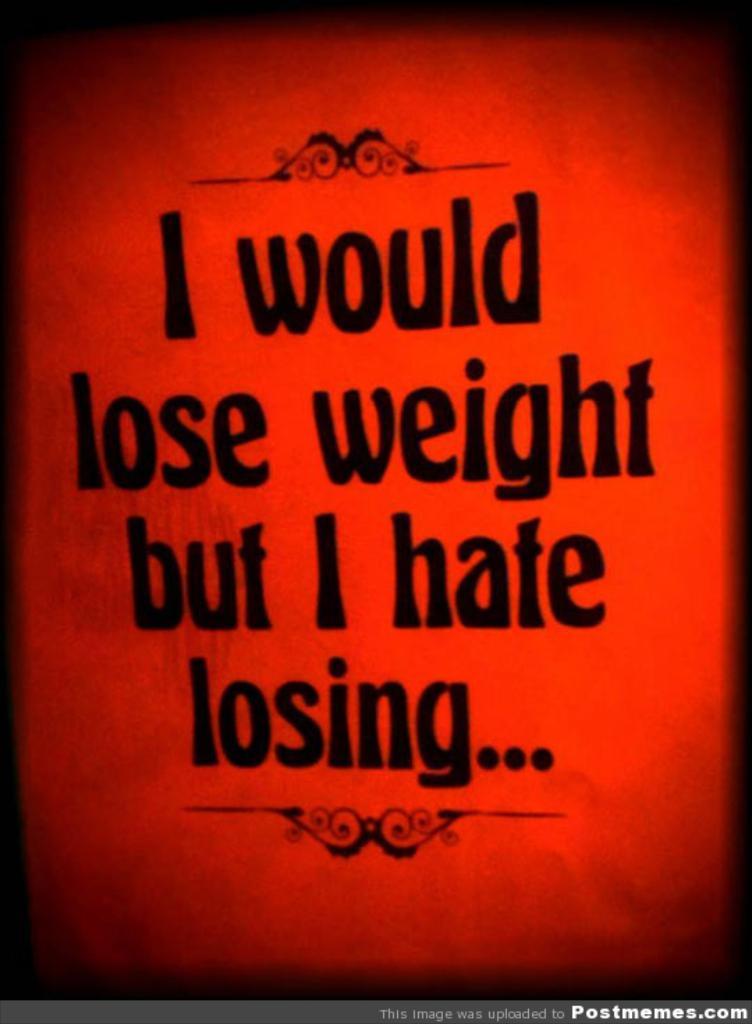What do they hate doing?
Offer a terse response. Losing. What would they lose?
Ensure brevity in your answer.  Weight. 